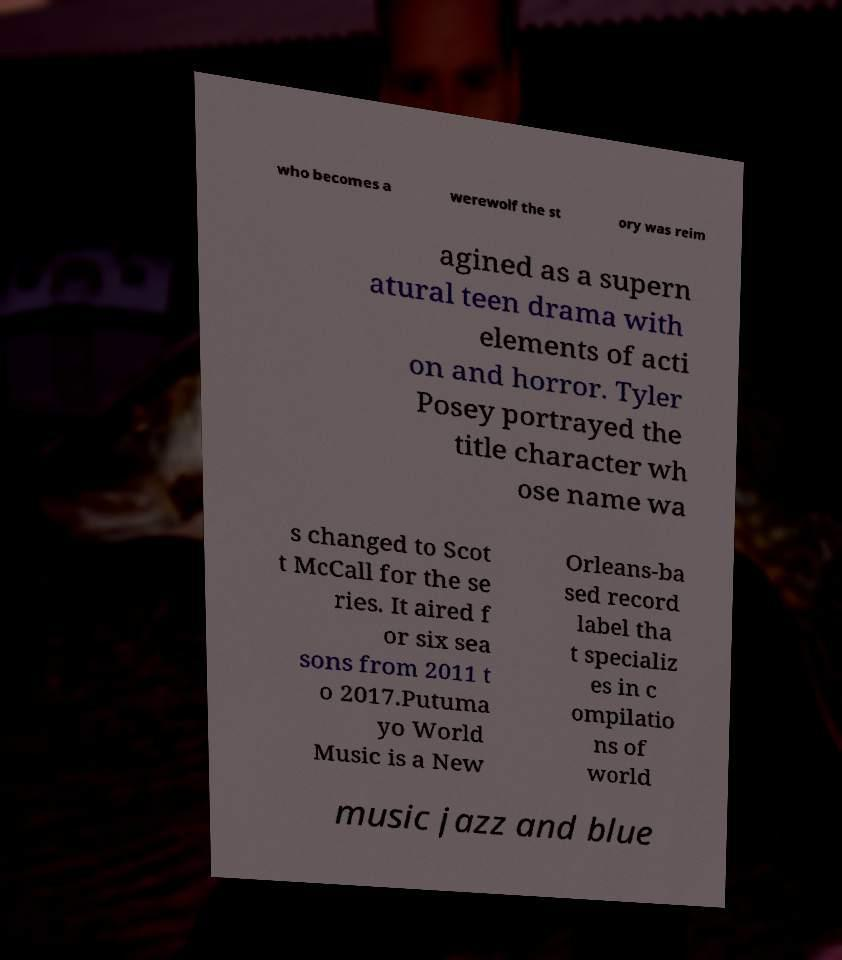Please identify and transcribe the text found in this image. who becomes a werewolf the st ory was reim agined as a supern atural teen drama with elements of acti on and horror. Tyler Posey portrayed the title character wh ose name wa s changed to Scot t McCall for the se ries. It aired f or six sea sons from 2011 t o 2017.Putuma yo World Music is a New Orleans-ba sed record label tha t specializ es in c ompilatio ns of world music jazz and blue 